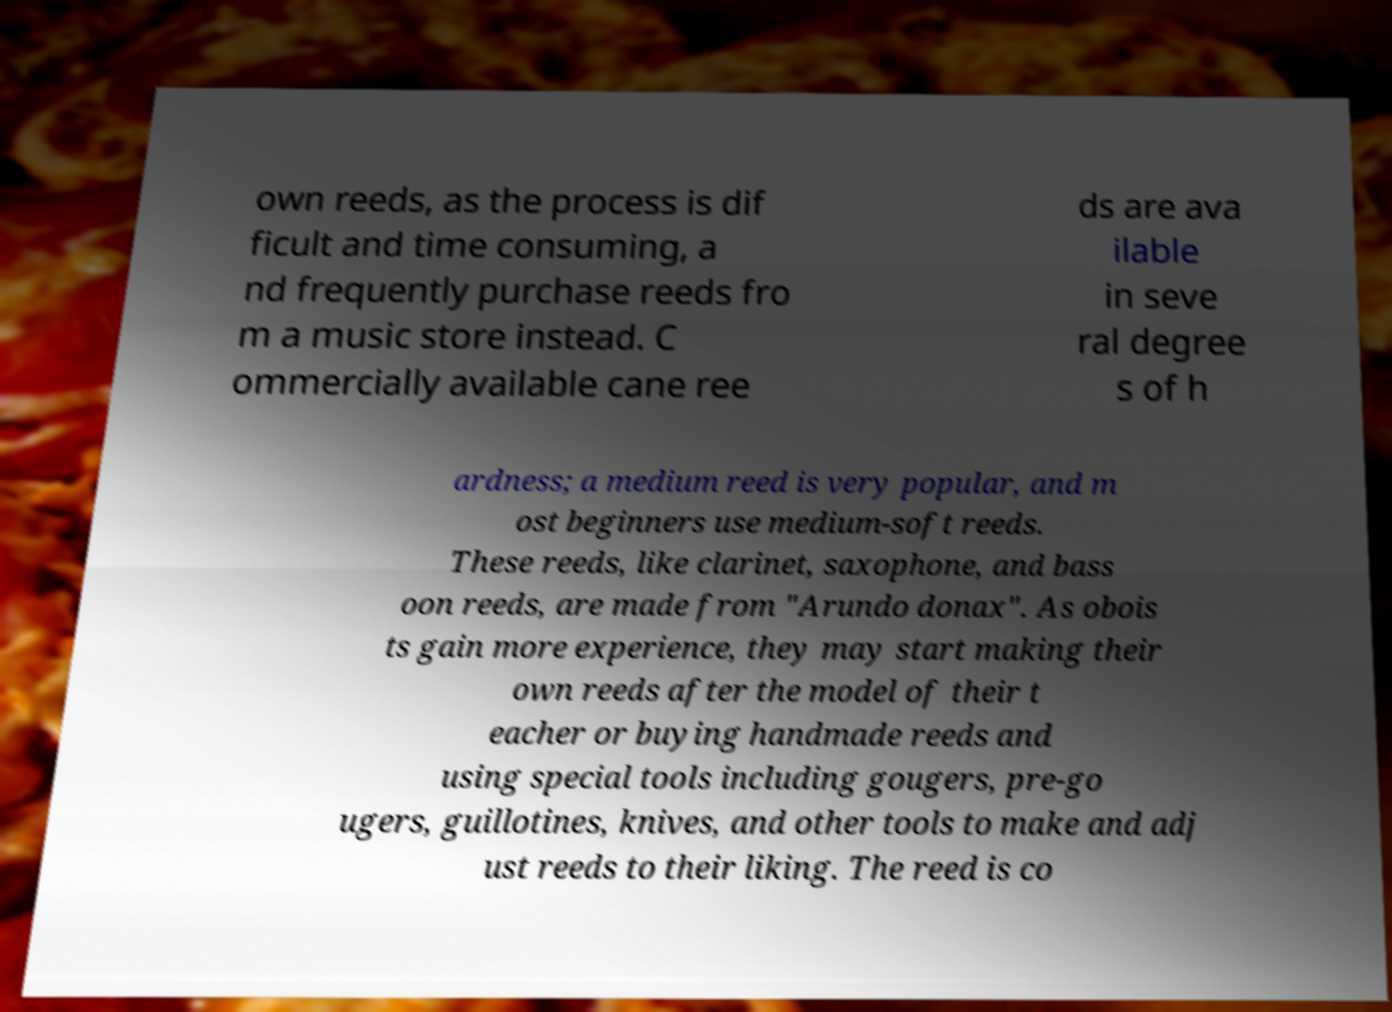Please identify and transcribe the text found in this image. own reeds, as the process is dif ficult and time consuming, a nd frequently purchase reeds fro m a music store instead. C ommercially available cane ree ds are ava ilable in seve ral degree s of h ardness; a medium reed is very popular, and m ost beginners use medium-soft reeds. These reeds, like clarinet, saxophone, and bass oon reeds, are made from "Arundo donax". As obois ts gain more experience, they may start making their own reeds after the model of their t eacher or buying handmade reeds and using special tools including gougers, pre-go ugers, guillotines, knives, and other tools to make and adj ust reeds to their liking. The reed is co 